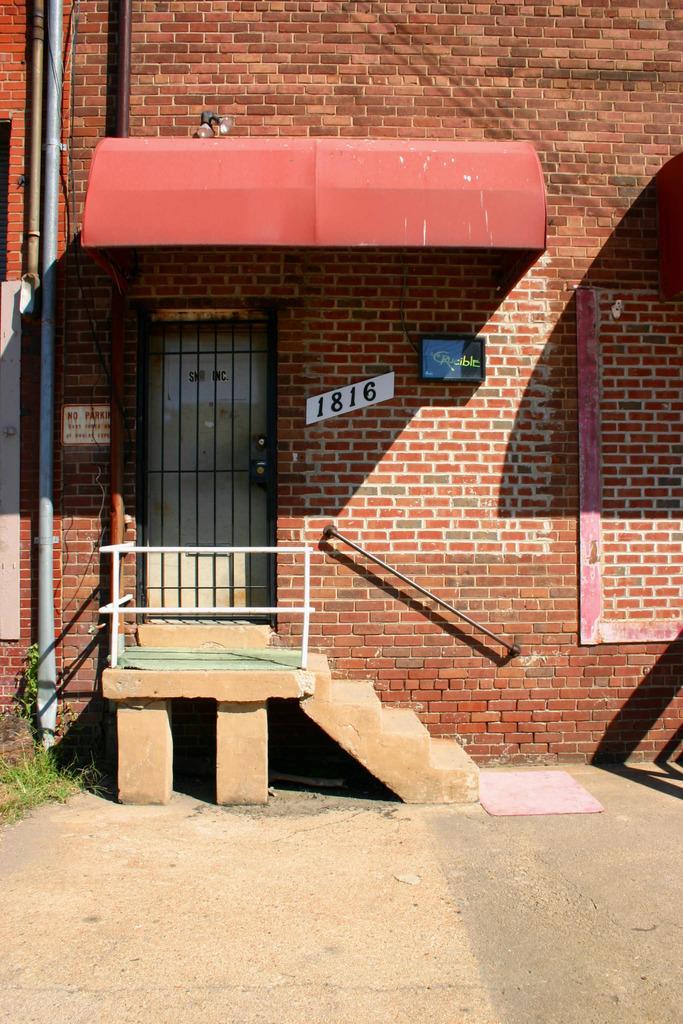Can you describe this image briefly? In this image we can see a wall with door, pipes, a board, lights, shed, there are stairs, railing and a mat on the ground. 